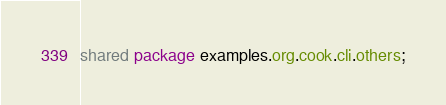<code> <loc_0><loc_0><loc_500><loc_500><_Ceylon_>shared package examples.org.cook.cli.others;
</code> 